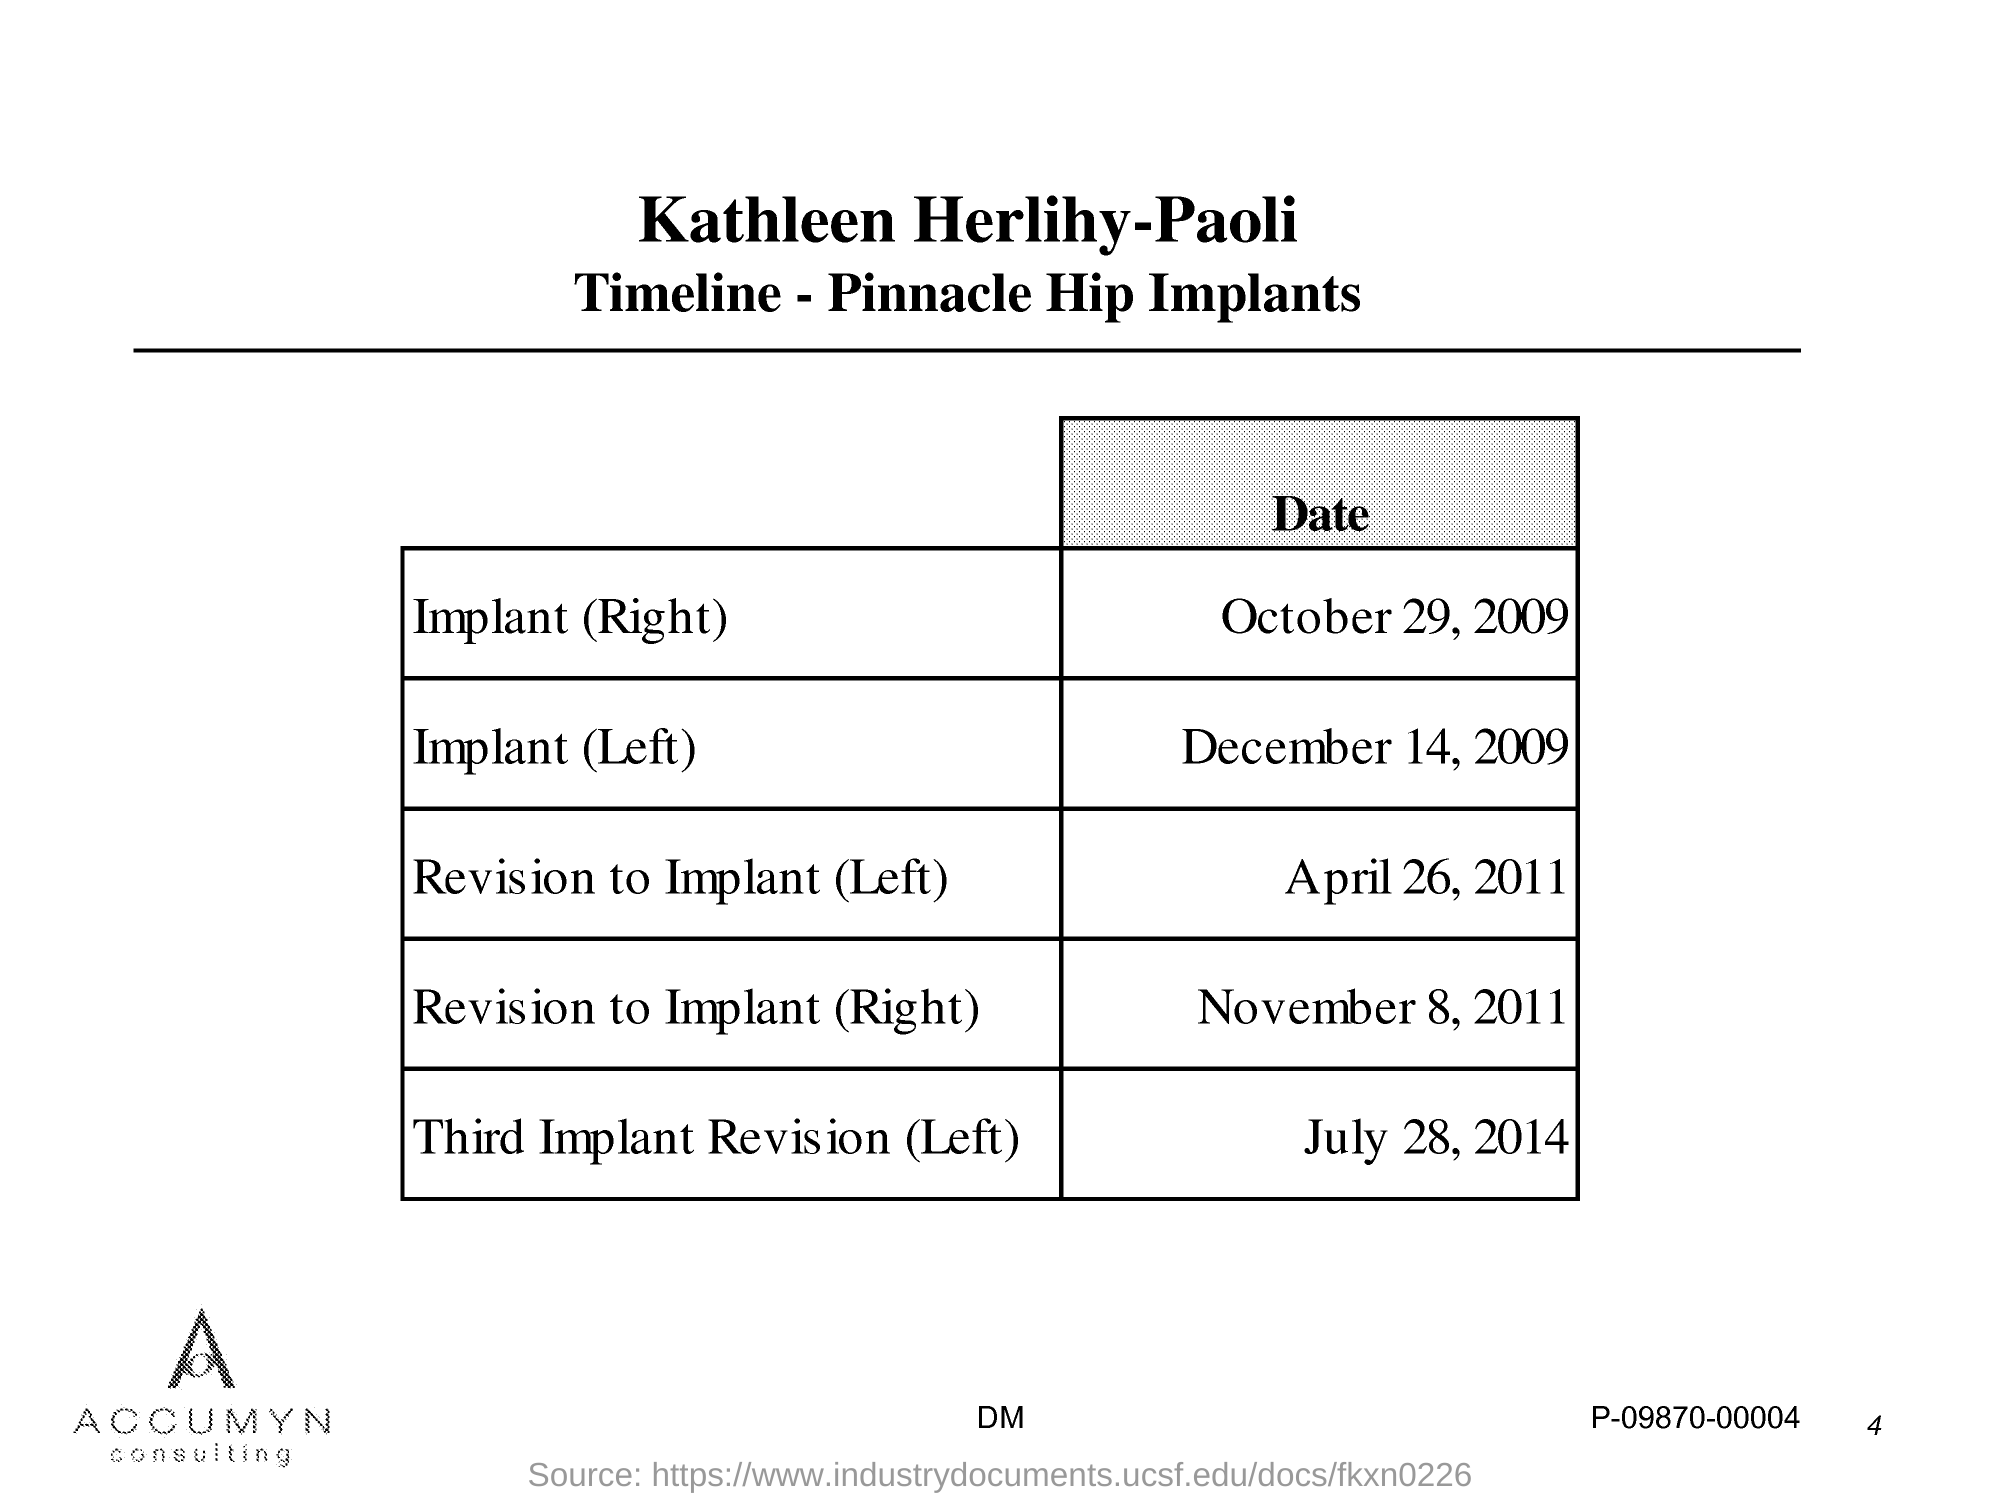Highlight a few significant elements in this photo. The date of implant on the left is December 14, 2009. The Date of Revision to Implant (Right) is November 8, 2011. The date of implant (right) is October 29, 2009. On April 26, 2011, the date of revision to implant (left) was taken. 